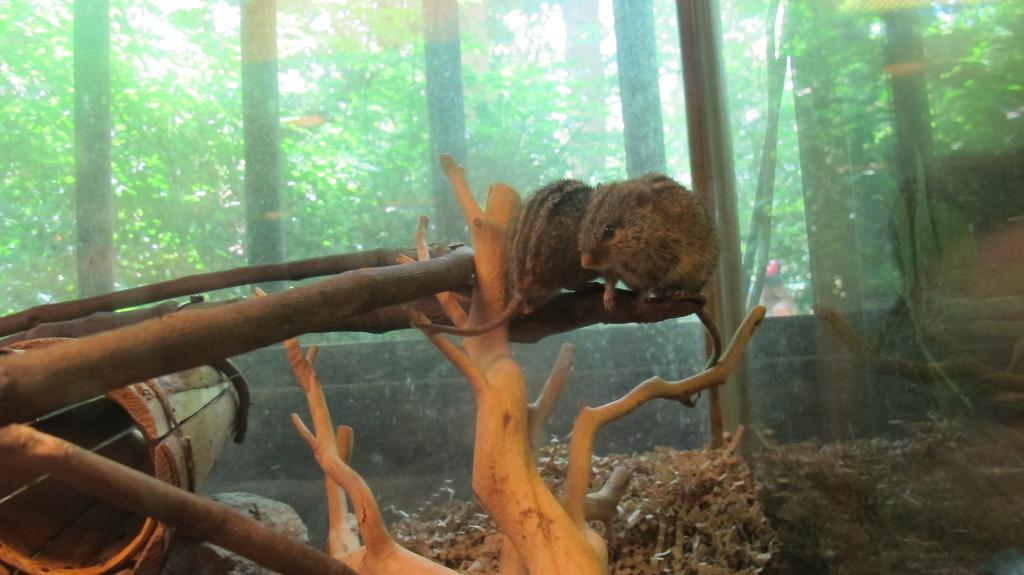Can you describe this image briefly? In this image we can see a squirrel sitting on the branch of a tree. In the background we can see trees, grills and sky. 